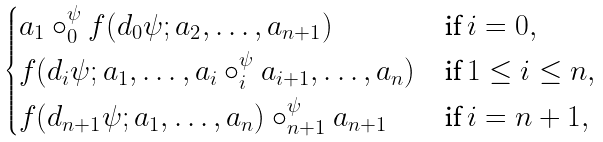<formula> <loc_0><loc_0><loc_500><loc_500>\begin{cases} a _ { 1 } \circ ^ { \psi } _ { 0 } f ( d _ { 0 } \psi ; a _ { 2 } , \dots , a _ { n + 1 } ) & \text {if } i = 0 , \\ f ( d _ { i } \psi ; a _ { 1 } , \dots , a _ { i } \circ ^ { \psi } _ { i } a _ { i + 1 } , \dots , a _ { n } ) & \text {if } 1 \leq i \leq n , \\ f ( d _ { n + 1 } \psi ; a _ { 1 } , \dots , a _ { n } ) \circ ^ { \psi } _ { n + 1 } a _ { n + 1 } & \text {if } i = n + 1 , \end{cases}</formula> 